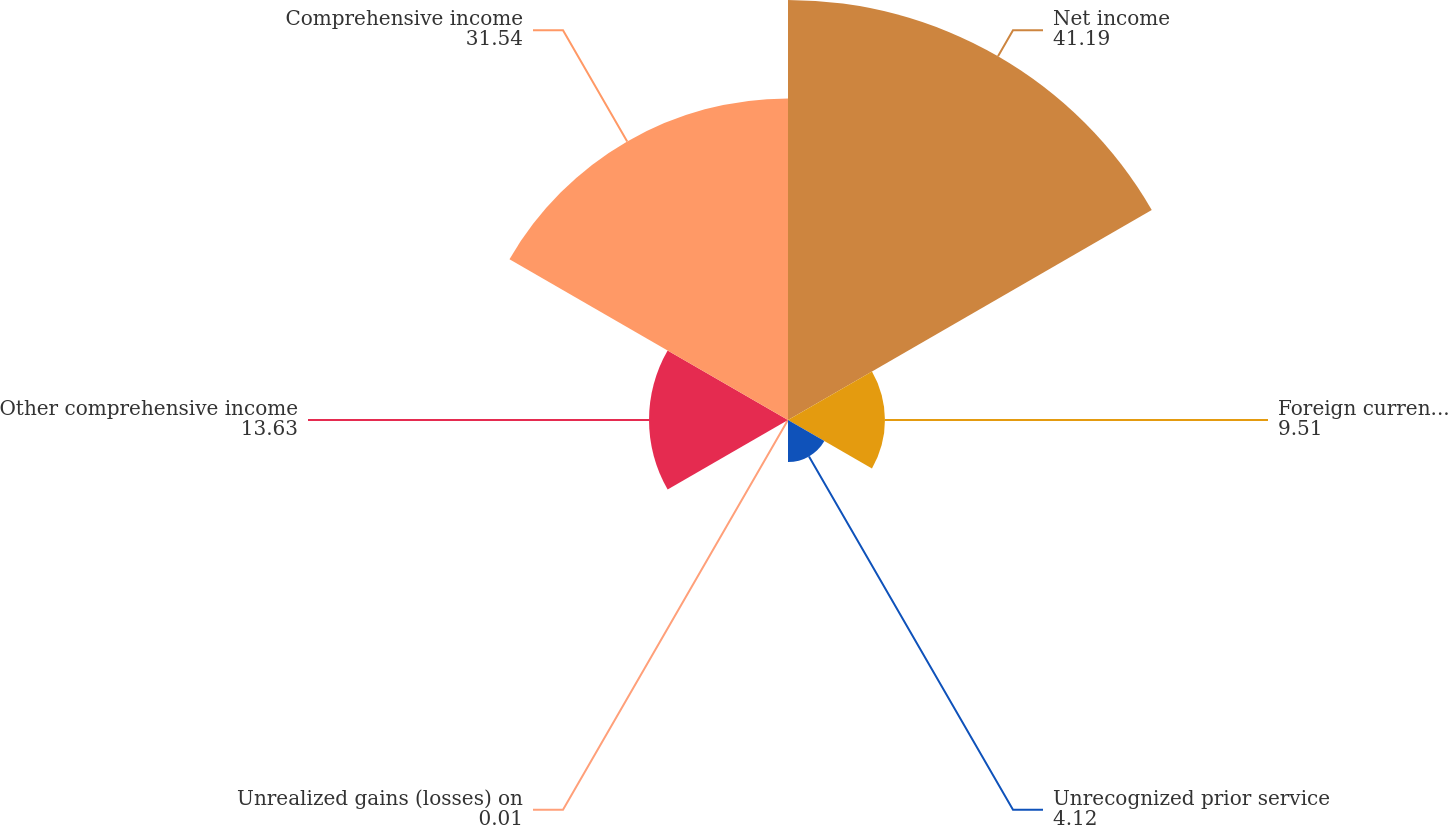Convert chart. <chart><loc_0><loc_0><loc_500><loc_500><pie_chart><fcel>Net income<fcel>Foreign currency translation<fcel>Unrecognized prior service<fcel>Unrealized gains (losses) on<fcel>Other comprehensive income<fcel>Comprehensive income<nl><fcel>41.19%<fcel>9.51%<fcel>4.12%<fcel>0.01%<fcel>13.63%<fcel>31.54%<nl></chart> 